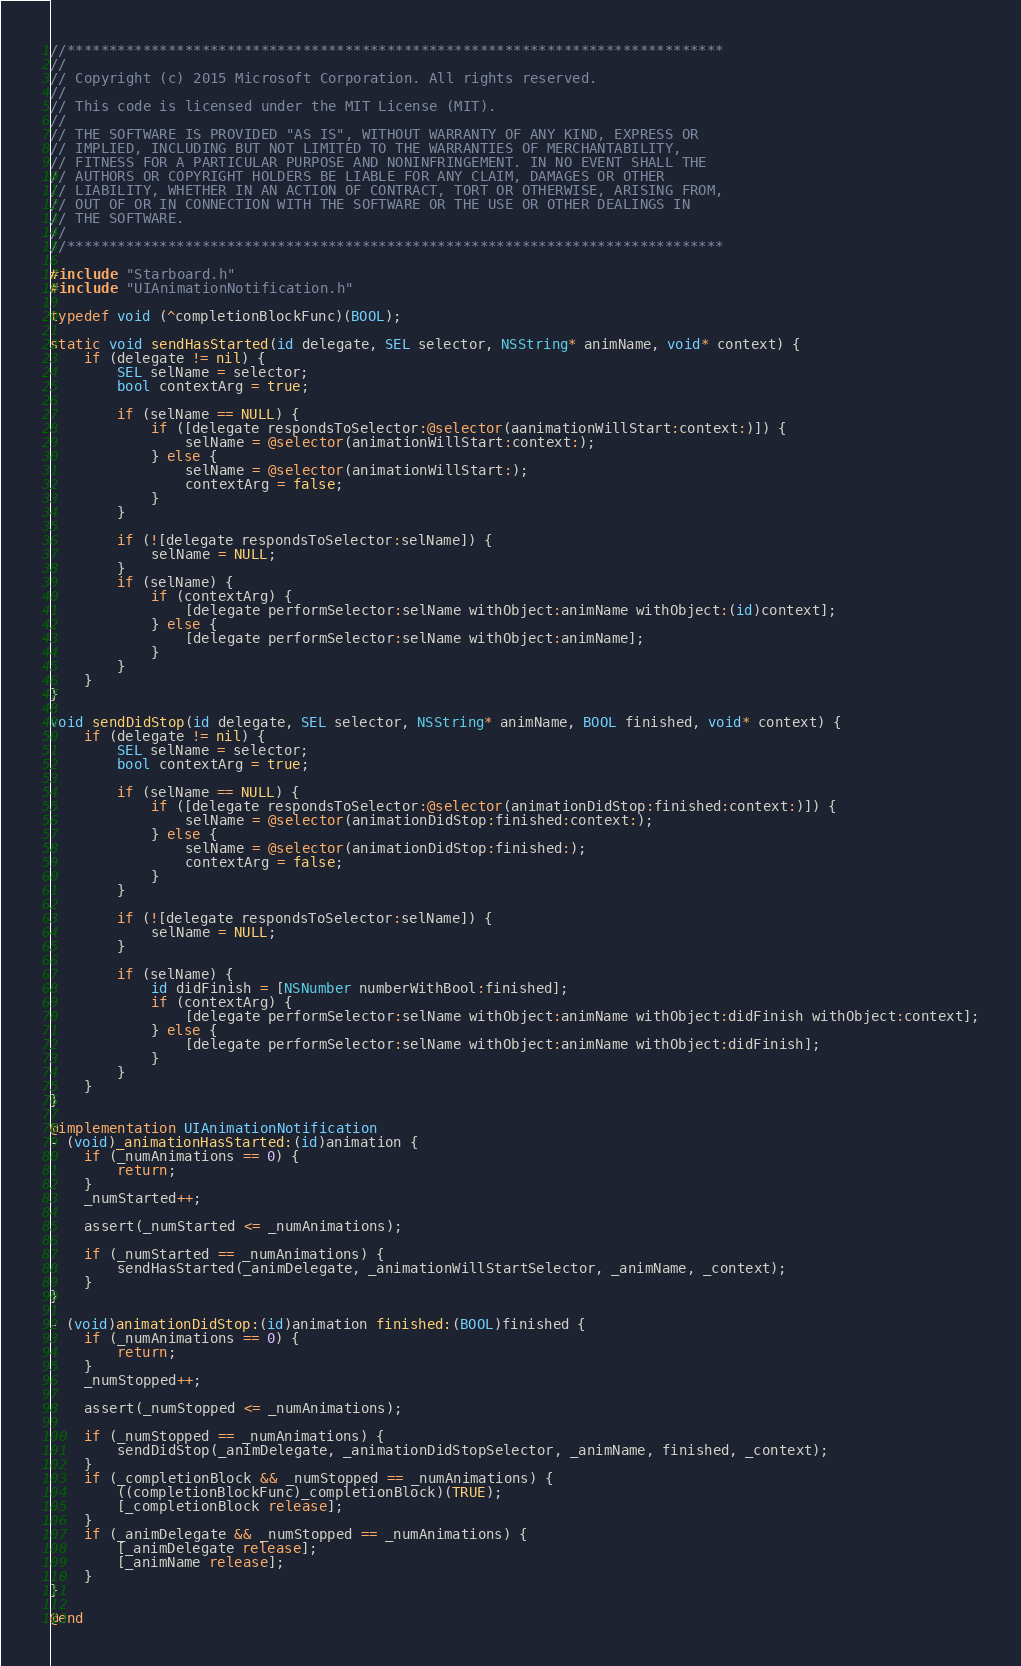Convert code to text. <code><loc_0><loc_0><loc_500><loc_500><_ObjectiveC_>//******************************************************************************
//
// Copyright (c) 2015 Microsoft Corporation. All rights reserved.
//
// This code is licensed under the MIT License (MIT).
//
// THE SOFTWARE IS PROVIDED "AS IS", WITHOUT WARRANTY OF ANY KIND, EXPRESS OR
// IMPLIED, INCLUDING BUT NOT LIMITED TO THE WARRANTIES OF MERCHANTABILITY,
// FITNESS FOR A PARTICULAR PURPOSE AND NONINFRINGEMENT. IN NO EVENT SHALL THE
// AUTHORS OR COPYRIGHT HOLDERS BE LIABLE FOR ANY CLAIM, DAMAGES OR OTHER
// LIABILITY, WHETHER IN AN ACTION OF CONTRACT, TORT OR OTHERWISE, ARISING FROM,
// OUT OF OR IN CONNECTION WITH THE SOFTWARE OR THE USE OR OTHER DEALINGS IN
// THE SOFTWARE.
//
//******************************************************************************

#include "Starboard.h"
#include "UIAnimationNotification.h"

typedef void (^completionBlockFunc)(BOOL);

static void sendHasStarted(id delegate, SEL selector, NSString* animName, void* context) {
    if (delegate != nil) {
        SEL selName = selector;
        bool contextArg = true;

        if (selName == NULL) {
            if ([delegate respondsToSelector:@selector(aanimationWillStart:context:)]) {
                selName = @selector(animationWillStart:context:);
            } else {
                selName = @selector(animationWillStart:);
                contextArg = false;
            }
        }

        if (![delegate respondsToSelector:selName]) {
            selName = NULL;
        }
        if (selName) {
            if (contextArg) {
                [delegate performSelector:selName withObject:animName withObject:(id)context];
            } else {
                [delegate performSelector:selName withObject:animName];
            }
        }
    }
}

void sendDidStop(id delegate, SEL selector, NSString* animName, BOOL finished, void* context) {
    if (delegate != nil) {
        SEL selName = selector;
        bool contextArg = true;

        if (selName == NULL) {
            if ([delegate respondsToSelector:@selector(animationDidStop:finished:context:)]) {
                selName = @selector(animationDidStop:finished:context:);
            } else {
                selName = @selector(animationDidStop:finished:);
                contextArg = false;
            }
        }

        if (![delegate respondsToSelector:selName]) {
            selName = NULL;
        }

        if (selName) {
            id didFinish = [NSNumber numberWithBool:finished];
            if (contextArg) {
                [delegate performSelector:selName withObject:animName withObject:didFinish withObject:context];
            } else {
                [delegate performSelector:selName withObject:animName withObject:didFinish];
            }
        }
    }
}

@implementation UIAnimationNotification
- (void)_animationHasStarted:(id)animation {
    if (_numAnimations == 0) {
        return;
    }
    _numStarted++;

    assert(_numStarted <= _numAnimations);

    if (_numStarted == _numAnimations) {
        sendHasStarted(_animDelegate, _animationWillStartSelector, _animName, _context);
    }
}

- (void)animationDidStop:(id)animation finished:(BOOL)finished {
    if (_numAnimations == 0) {
        return;
    }
    _numStopped++;

    assert(_numStopped <= _numAnimations);

    if (_numStopped == _numAnimations) {
        sendDidStop(_animDelegate, _animationDidStopSelector, _animName, finished, _context);
    }
    if (_completionBlock && _numStopped == _numAnimations) {
        ((completionBlockFunc)_completionBlock)(TRUE);
        [_completionBlock release];
    }
    if (_animDelegate && _numStopped == _numAnimations) {
        [_animDelegate release];
        [_animName release];
    }
}

@end
</code> 